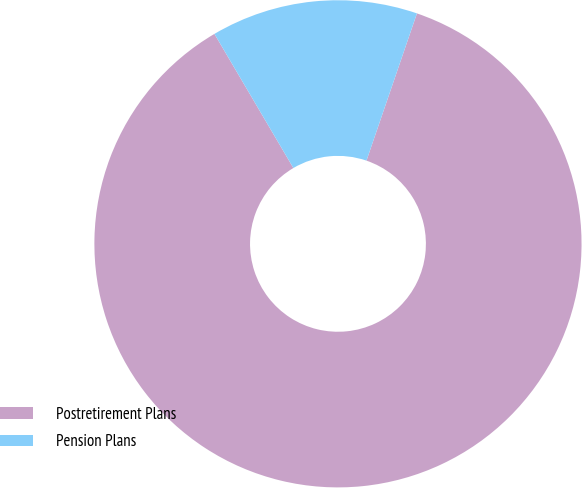Convert chart to OTSL. <chart><loc_0><loc_0><loc_500><loc_500><pie_chart><fcel>Postretirement Plans<fcel>Pension Plans<nl><fcel>86.28%<fcel>13.72%<nl></chart> 